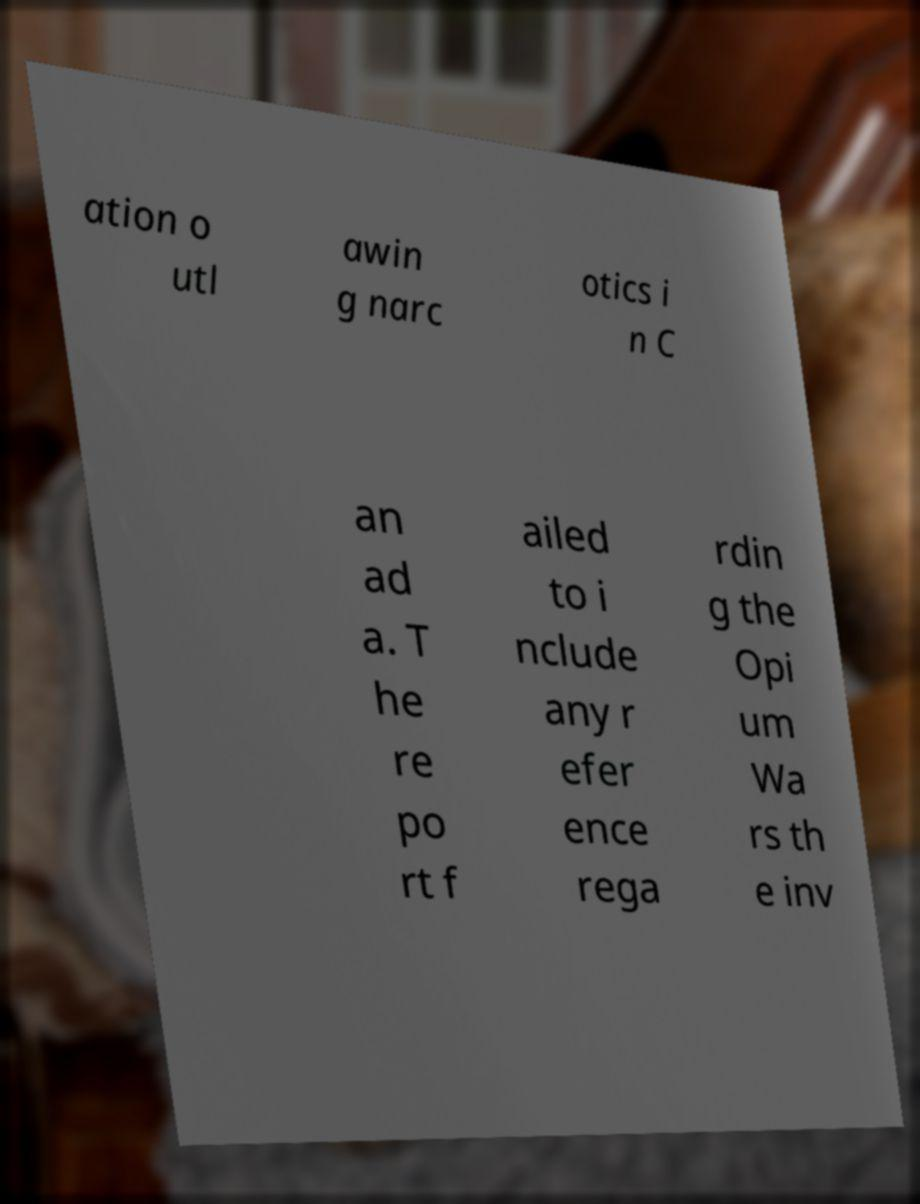For documentation purposes, I need the text within this image transcribed. Could you provide that? ation o utl awin g narc otics i n C an ad a. T he re po rt f ailed to i nclude any r efer ence rega rdin g the Opi um Wa rs th e inv 